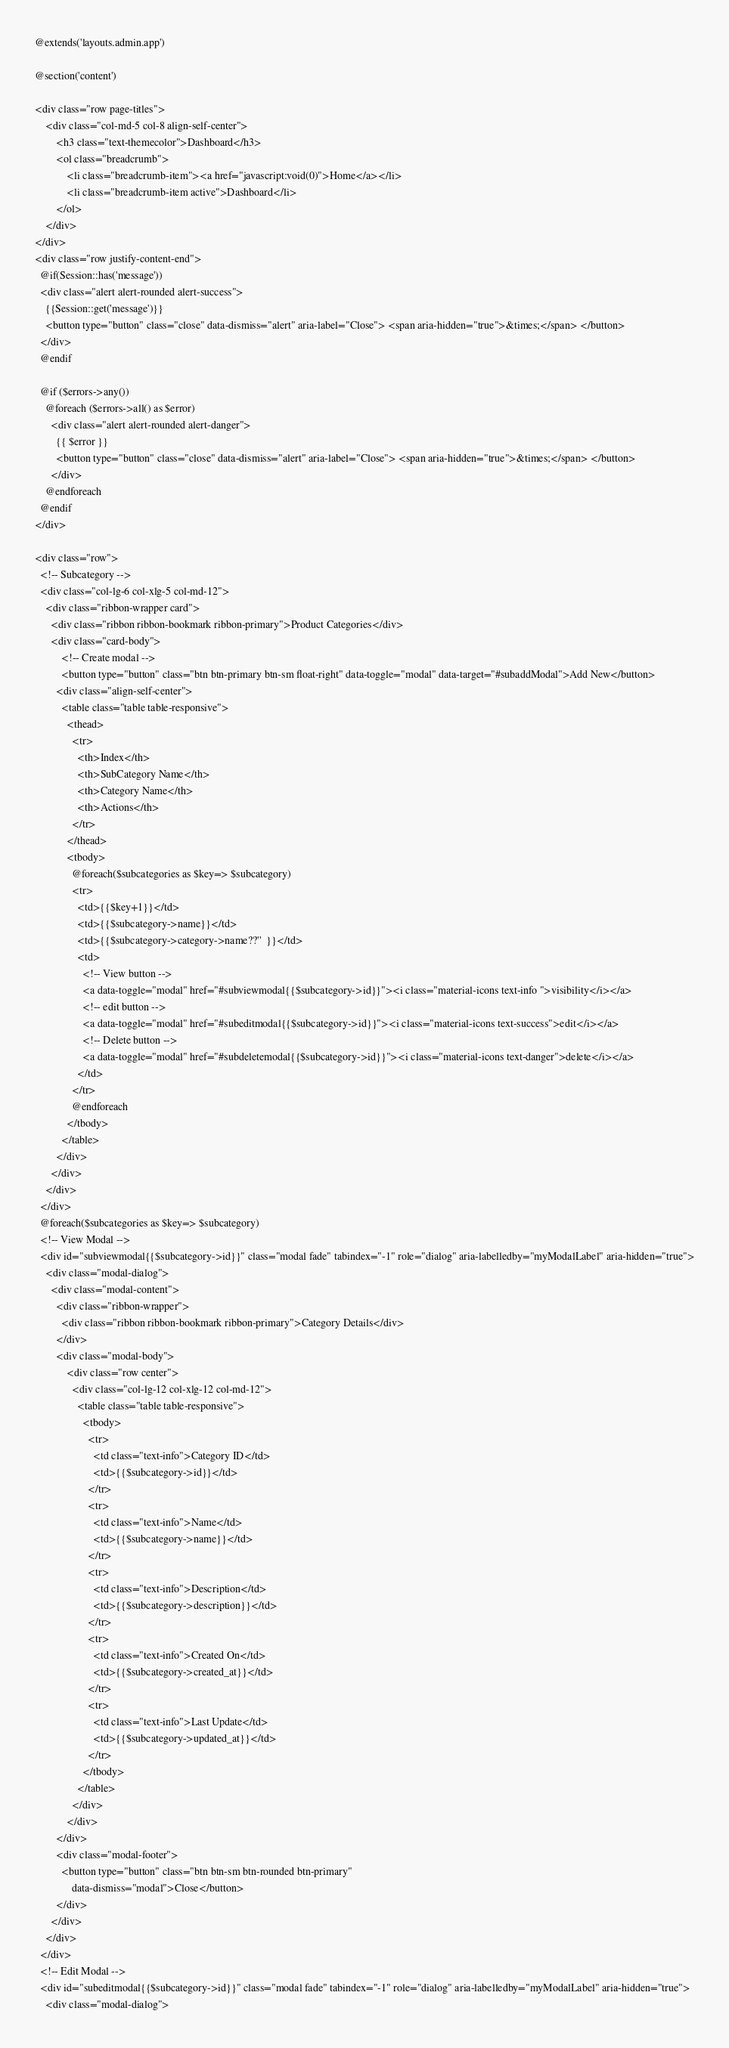<code> <loc_0><loc_0><loc_500><loc_500><_PHP_>@extends('layouts.admin.app')

@section('content')

<div class="row page-titles">
    <div class="col-md-5 col-8 align-self-center">
        <h3 class="text-themecolor">Dashboard</h3>
        <ol class="breadcrumb">
            <li class="breadcrumb-item"><a href="javascript:void(0)">Home</a></li>
            <li class="breadcrumb-item active">Dashboard</li>
        </ol>
    </div>
</div>
<div class="row justify-content-end">
  @if(Session::has('message'))
  <div class="alert alert-rounded alert-success">
    {{Session::get('message')}}
    <button type="button" class="close" data-dismiss="alert" aria-label="Close"> <span aria-hidden="true">&times;</span> </button>
  </div>
  @endif

  @if ($errors->any())
    @foreach ($errors->all() as $error) 
      <div class="alert alert-rounded alert-danger">
        {{ $error }}
        <button type="button" class="close" data-dismiss="alert" aria-label="Close"> <span aria-hidden="true">&times;</span> </button>
      </div>
    @endforeach
  @endif
</div>

<div class="row">
  <!-- Subcategory -->
  <div class="col-lg-6 col-xlg-5 col-md-12">
    <div class="ribbon-wrapper card">
      <div class="ribbon ribbon-bookmark ribbon-primary">Product Categories</div>
      <div class="card-body">
          <!-- Create modal -->
          <button type="button" class="btn btn-primary btn-sm float-right" data-toggle="modal" data-target="#subaddModal">Add New</button>
        <div class="align-self-center">
          <table class="table table-responsive">
            <thead>
              <tr>
                <th>Index</th>
                <th>SubCategory Name</th>
                <th>Category Name</th>
                <th>Actions</th>
              </tr>
            </thead>
            <tbody>
              @foreach($subcategories as $key=> $subcategory)
              <tr>
                <td>{{$key+1}}</td>
                <td>{{$subcategory->name}}</td>
                <td>{{$subcategory->category->name??''  }}</td>           
                <td>
                  <!-- View button -->
                  <a data-toggle="modal" href="#subviewmodal{{$subcategory->id}}"><i class="material-icons text-info ">visibility</i></a>
                  <!-- edit button -->
                  <a data-toggle="modal" href="#subeditmodal{{$subcategory->id}}"><i class="material-icons text-success">edit</i></a>
                  <!-- Delete button -->
                  <a data-toggle="modal" href="#subdeletemodal{{$subcategory->id}}"><i class="material-icons text-danger">delete</i></a>
                </td>
              </tr>
              @endforeach
            </tbody>
          </table>
        </div>
      </div>
    </div>
  </div>
  @foreach($subcategories as $key=> $subcategory)
  <!-- View Modal -->
  <div id="subviewmodal{{$subcategory->id}}" class="modal fade" tabindex="-1" role="dialog" aria-labelledby="myModalLabel" aria-hidden="true">
    <div class="modal-dialog">
      <div class="modal-content">
        <div class="ribbon-wrapper">
          <div class="ribbon ribbon-bookmark ribbon-primary">Category Details</div>
        </div>
        <div class="modal-body">
            <div class="row center">
              <div class="col-lg-12 col-xlg-12 col-md-12">
                <table class="table table-responsive">
                  <tbody>
                    <tr>
                      <td class="text-info">Category ID</td>
                      <td>{{$subcategory->id}}</td>
                    </tr>
                    <tr>
                      <td class="text-info">Name</td>
                      <td>{{$subcategory->name}}</td>
                    </tr>
                    <tr>
                      <td class="text-info">Description</td>
                      <td>{{$subcategory->description}}</td>
                    </tr>
                    <tr>
                      <td class="text-info">Created On</td>
                      <td>{{$subcategory->created_at}}</td>
                    </tr>
                    <tr>
                      <td class="text-info">Last Update</td>
                      <td>{{$subcategory->updated_at}}</td>
                    </tr>
                  </tbody>
                </table>
              </div>
            </div>
        </div>
        <div class="modal-footer">
          <button type="button" class="btn btn-sm btn-rounded btn-primary"
              data-dismiss="modal">Close</button>
        </div>
      </div>
    </div>
  </div>
  <!-- Edit Modal -->
  <div id="subeditmodal{{$subcategory->id}}" class="modal fade" tabindex="-1" role="dialog" aria-labelledby="myModalLabel" aria-hidden="true">
    <div class="modal-dialog"></code> 